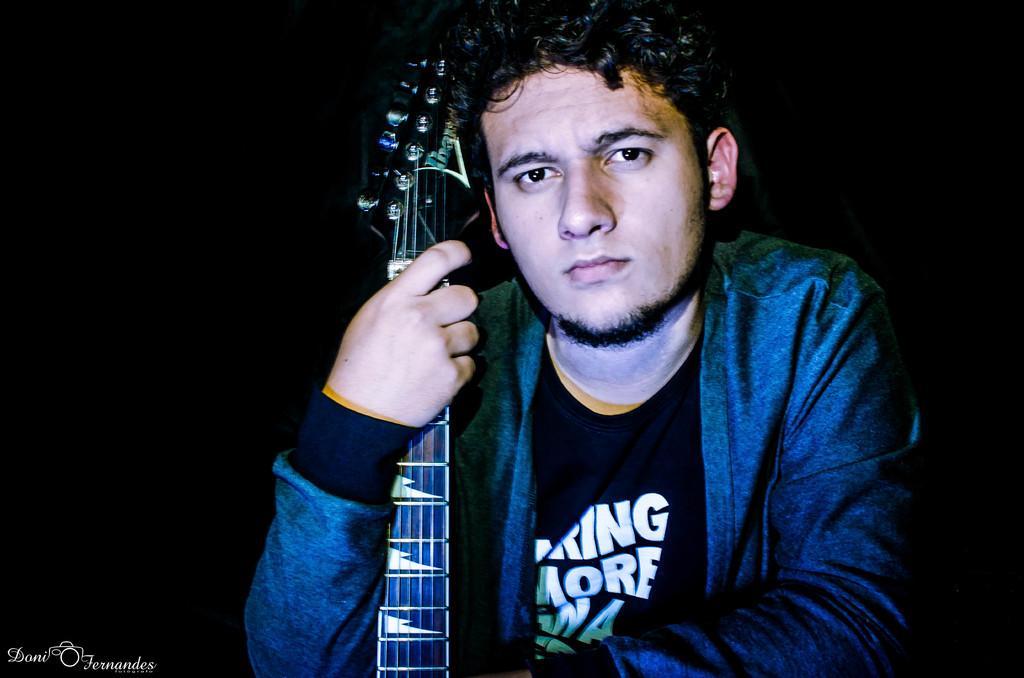Could you give a brief overview of what you see in this image? In this image there is a person holding a guitar in his hand and there is a dark background. 